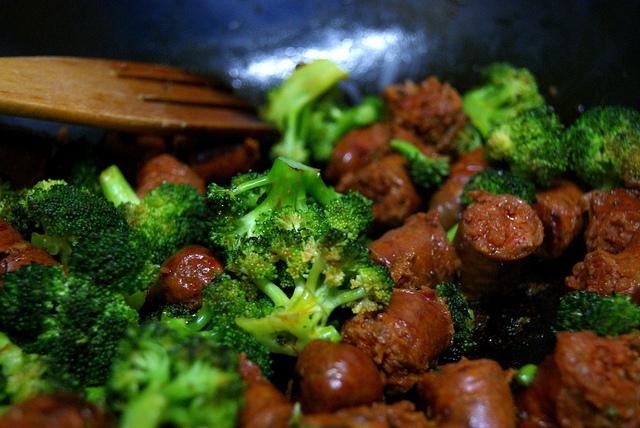What color is the spatula?
Write a very short answer. Brown. Has the food been cooked?
Keep it brief. Yes. What vegetables are shown?
Keep it brief. Broccoli. 